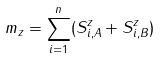Convert formula to latex. <formula><loc_0><loc_0><loc_500><loc_500>m _ { z } = \sum _ { i = 1 } ^ { n } ( S ^ { z } _ { i , A } + S ^ { z } _ { i , B } )</formula> 